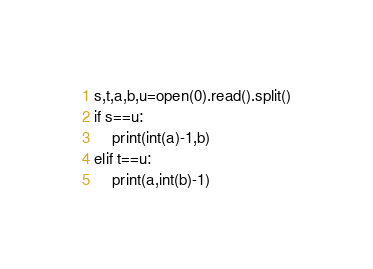<code> <loc_0><loc_0><loc_500><loc_500><_Python_>s,t,a,b,u=open(0).read().split()
if s==u:
    print(int(a)-1,b)
elif t==u:
    print(a,int(b)-1)</code> 